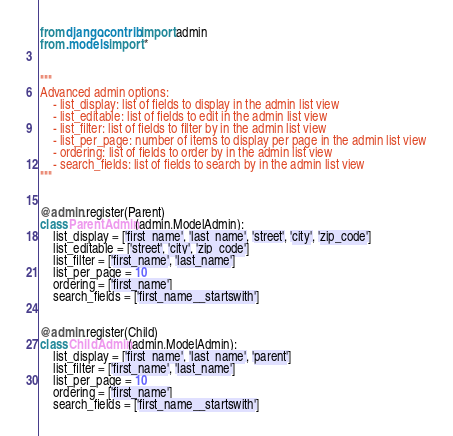<code> <loc_0><loc_0><loc_500><loc_500><_Python_>from django.contrib import admin
from .models import *


"""
Advanced admin options:
    - list_display: list of fields to display in the admin list view
    - list_editable: list of fields to edit in the admin list view
    - list_filter: list of fields to filter by in the admin list view
    - list_per_page: number of items to display per page in the admin list view
    - ordering: list of fields to order by in the admin list view
    - search_fields: list of fields to search by in the admin list view
"""


@admin.register(Parent)
class ParentAdmin(admin.ModelAdmin):
    list_display = ['first_name', 'last_name', 'street', 'city', 'zip_code']
    list_editable = ['street', 'city', 'zip_code']
    list_filter = ['first_name', 'last_name']
    list_per_page = 10
    ordering = ['first_name']
    search_fields = ['first_name__startswith']


@admin.register(Child)
class ChildAdmin(admin.ModelAdmin):
    list_display = ['first_name', 'last_name', 'parent']
    list_filter = ['first_name', 'last_name']
    list_per_page = 10
    ordering = ['first_name']
    search_fields = ['first_name__startswith']
</code> 